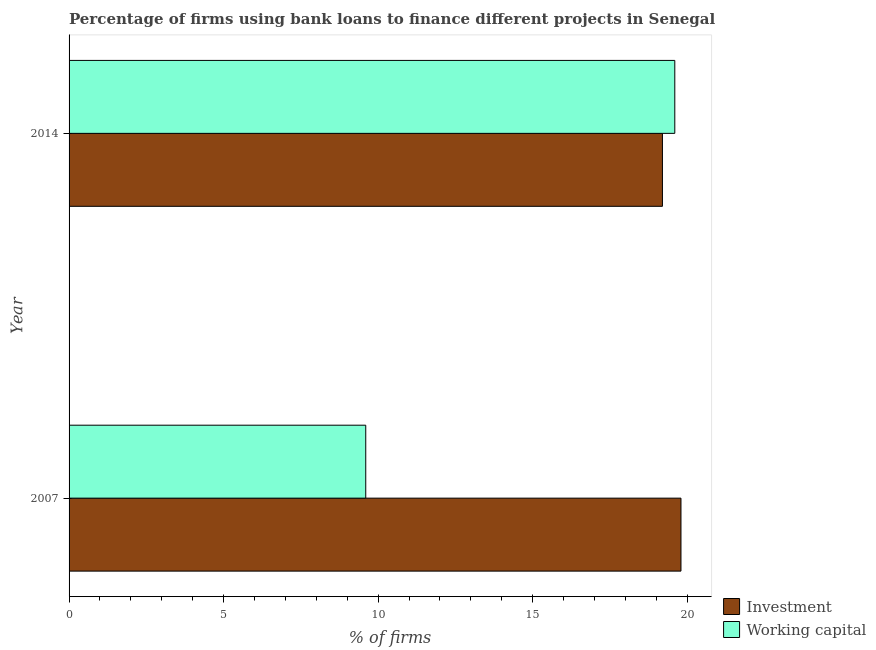Are the number of bars per tick equal to the number of legend labels?
Your answer should be compact. Yes. Are the number of bars on each tick of the Y-axis equal?
Offer a terse response. Yes. How many bars are there on the 2nd tick from the bottom?
Your response must be concise. 2. Across all years, what is the maximum percentage of firms using banks to finance working capital?
Make the answer very short. 19.6. What is the difference between the percentage of firms using banks to finance investment in 2007 and that in 2014?
Your response must be concise. 0.6. What is the difference between the percentage of firms using banks to finance investment in 2007 and the percentage of firms using banks to finance working capital in 2014?
Ensure brevity in your answer.  0.2. What is the ratio of the percentage of firms using banks to finance investment in 2007 to that in 2014?
Keep it short and to the point. 1.03. Is the difference between the percentage of firms using banks to finance investment in 2007 and 2014 greater than the difference between the percentage of firms using banks to finance working capital in 2007 and 2014?
Provide a short and direct response. Yes. In how many years, is the percentage of firms using banks to finance working capital greater than the average percentage of firms using banks to finance working capital taken over all years?
Provide a succinct answer. 1. What does the 1st bar from the top in 2007 represents?
Make the answer very short. Working capital. What does the 1st bar from the bottom in 2014 represents?
Offer a very short reply. Investment. How many bars are there?
Make the answer very short. 4. Are all the bars in the graph horizontal?
Offer a terse response. Yes. Are the values on the major ticks of X-axis written in scientific E-notation?
Offer a terse response. No. How many legend labels are there?
Provide a succinct answer. 2. How are the legend labels stacked?
Give a very brief answer. Vertical. What is the title of the graph?
Give a very brief answer. Percentage of firms using bank loans to finance different projects in Senegal. Does "Chemicals" appear as one of the legend labels in the graph?
Your answer should be compact. No. What is the label or title of the X-axis?
Ensure brevity in your answer.  % of firms. What is the % of firms in Investment in 2007?
Your answer should be compact. 19.8. What is the % of firms of Working capital in 2007?
Keep it short and to the point. 9.6. What is the % of firms of Investment in 2014?
Offer a very short reply. 19.2. What is the % of firms of Working capital in 2014?
Offer a very short reply. 19.6. Across all years, what is the maximum % of firms of Investment?
Offer a very short reply. 19.8. Across all years, what is the maximum % of firms of Working capital?
Your response must be concise. 19.6. Across all years, what is the minimum % of firms of Investment?
Provide a short and direct response. 19.2. Across all years, what is the minimum % of firms in Working capital?
Provide a succinct answer. 9.6. What is the total % of firms in Investment in the graph?
Offer a very short reply. 39. What is the total % of firms in Working capital in the graph?
Offer a very short reply. 29.2. What is the difference between the % of firms in Investment in 2007 and the % of firms in Working capital in 2014?
Keep it short and to the point. 0.2. What is the average % of firms of Investment per year?
Offer a terse response. 19.5. What is the average % of firms in Working capital per year?
Provide a short and direct response. 14.6. In the year 2014, what is the difference between the % of firms of Investment and % of firms of Working capital?
Provide a short and direct response. -0.4. What is the ratio of the % of firms of Investment in 2007 to that in 2014?
Give a very brief answer. 1.03. What is the ratio of the % of firms of Working capital in 2007 to that in 2014?
Provide a succinct answer. 0.49. What is the difference between the highest and the second highest % of firms of Investment?
Your answer should be very brief. 0.6. What is the difference between the highest and the second highest % of firms of Working capital?
Your answer should be compact. 10. 